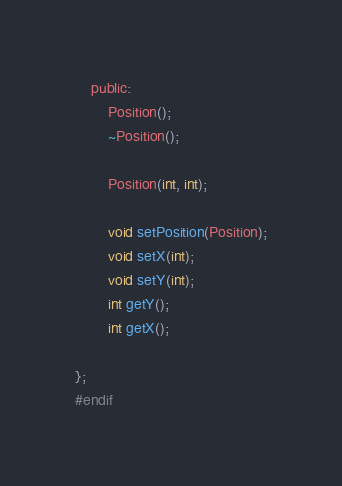Convert code to text. <code><loc_0><loc_0><loc_500><loc_500><_C_>    public:
        Position();
        ~Position();

        Position(int, int);

        void setPosition(Position);
        void setX(int);
        void setY(int);
        int getY();
        int getX();

};
#endif</code> 